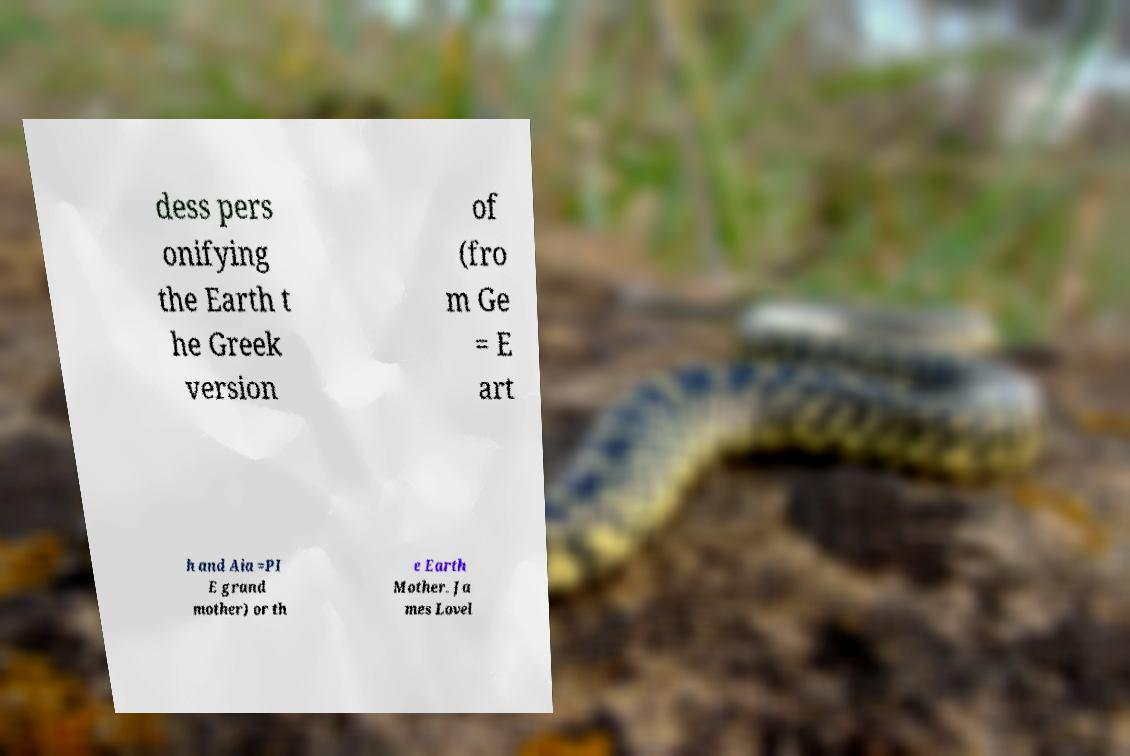Could you extract and type out the text from this image? dess pers onifying the Earth t he Greek version of (fro m Ge = E art h and Aia =PI E grand mother) or th e Earth Mother. Ja mes Lovel 